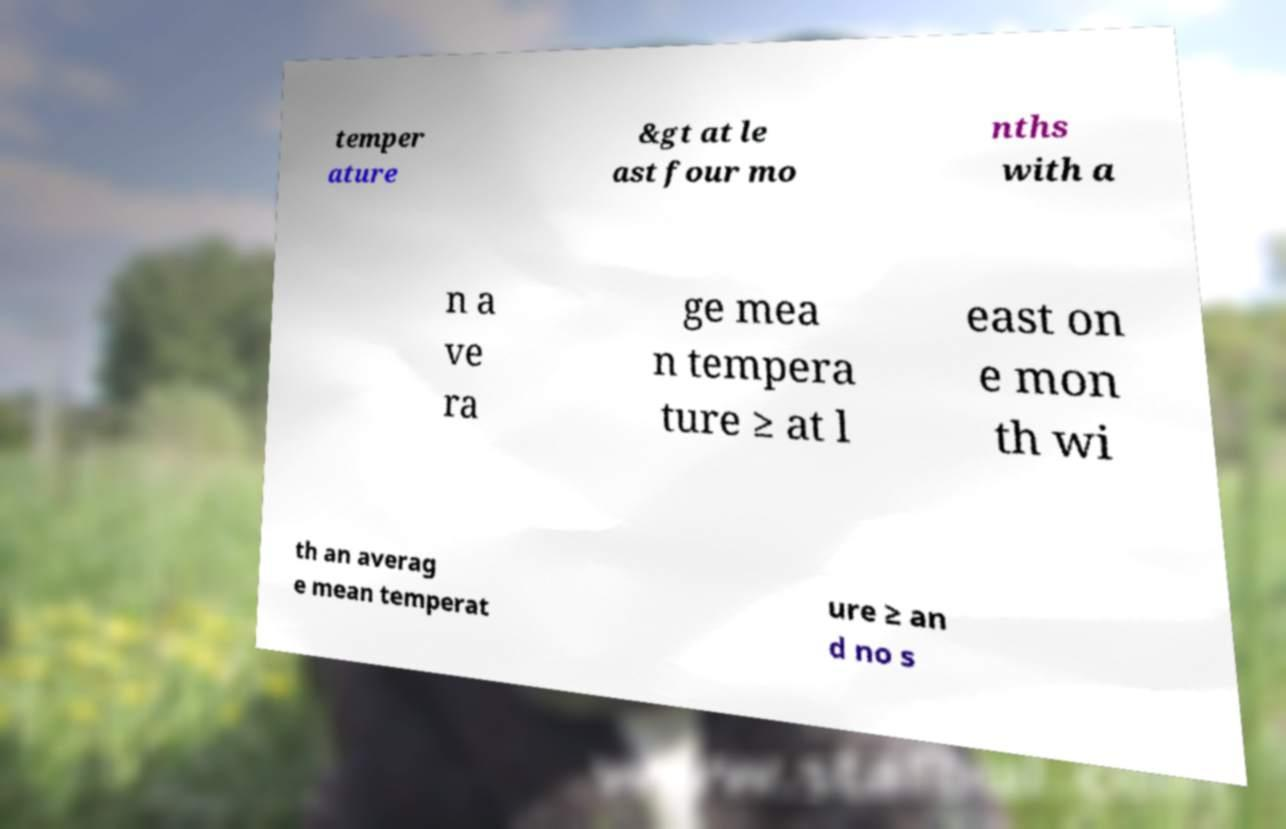I need the written content from this picture converted into text. Can you do that? temper ature &gt at le ast four mo nths with a n a ve ra ge mea n tempera ture ≥ at l east on e mon th wi th an averag e mean temperat ure ≥ an d no s 